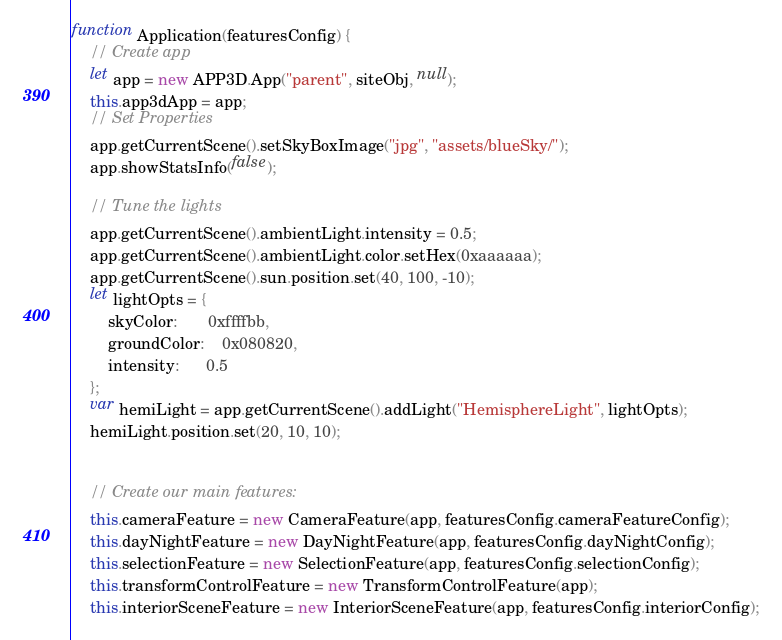Convert code to text. <code><loc_0><loc_0><loc_500><loc_500><_JavaScript_>function Application(featuresConfig) {
    // Create app
    let app = new APP3D.App("parent", siteObj, null);
    this.app3dApp = app;
    // Set Properties
    app.getCurrentScene().setSkyBoxImage("jpg", "assets/blueSky/");
    app.showStatsInfo(false);

    // Tune the lights
    app.getCurrentScene().ambientLight.intensity = 0.5;
    app.getCurrentScene().ambientLight.color.setHex(0xaaaaaa);
    app.getCurrentScene().sun.position.set(40, 100, -10);
    let lightOpts = {
        skyColor:       0xffffbb,
        groundColor:    0x080820,
        intensity:      0.5
    };
    var hemiLight = app.getCurrentScene().addLight("HemisphereLight", lightOpts);
    hemiLight.position.set(20, 10, 10);


    // Create our main features:
    this.cameraFeature = new CameraFeature(app, featuresConfig.cameraFeatureConfig);
    this.dayNightFeature = new DayNightFeature(app, featuresConfig.dayNightConfig);
    this.selectionFeature = new SelectionFeature(app, featuresConfig.selectionConfig);
    this.transformControlFeature = new TransformControlFeature(app);
    this.interiorSceneFeature = new InteriorSceneFeature(app, featuresConfig.interiorConfig);</code> 